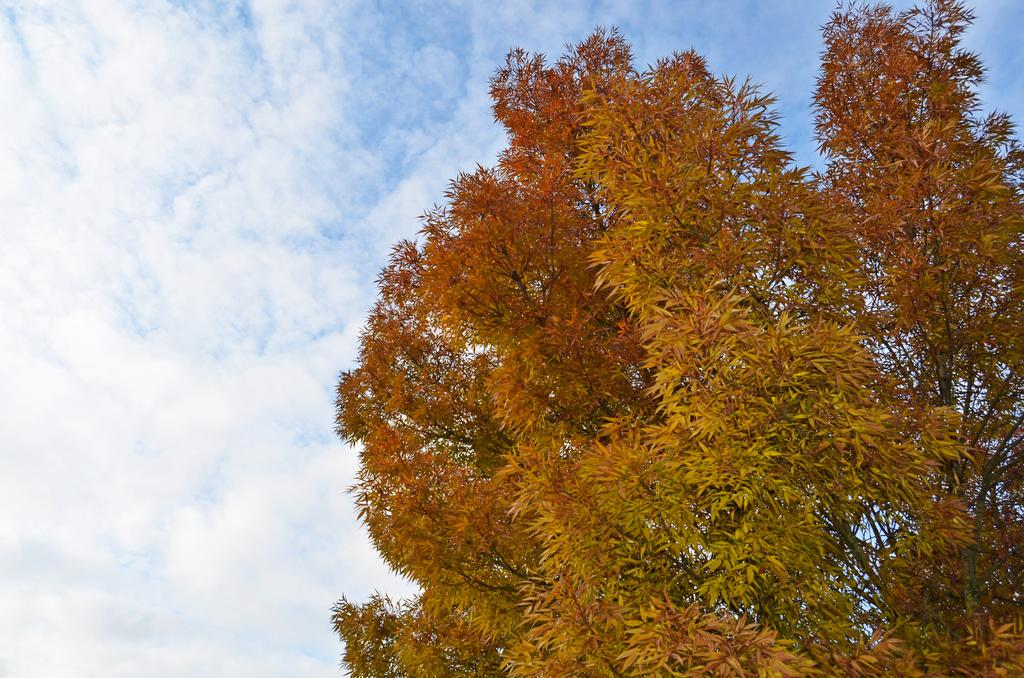What type of vegetation is on the right side of the image? There is a tree at the right side of the image. What is the condition of the sky in the image? The sky is clear in the image. What type of force is being exerted on the tree in the image? There is no indication of any force being exerted on the tree in the image. How does the tree provide support to the surrounding environment in the image? The tree is not shown providing support to the surrounding environment in the image. 